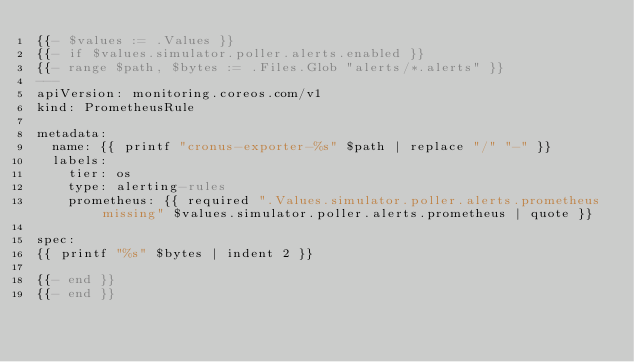Convert code to text. <code><loc_0><loc_0><loc_500><loc_500><_YAML_>{{- $values := .Values }}
{{- if $values.simulator.poller.alerts.enabled }}
{{- range $path, $bytes := .Files.Glob "alerts/*.alerts" }}
---
apiVersion: monitoring.coreos.com/v1
kind: PrometheusRule

metadata:
  name: {{ printf "cronus-exporter-%s" $path | replace "/" "-" }}
  labels:
    tier: os
    type: alerting-rules
    prometheus: {{ required ".Values.simulator.poller.alerts.prometheus missing" $values.simulator.poller.alerts.prometheus | quote }}

spec:
{{ printf "%s" $bytes | indent 2 }}

{{- end }}
{{- end }}</code> 